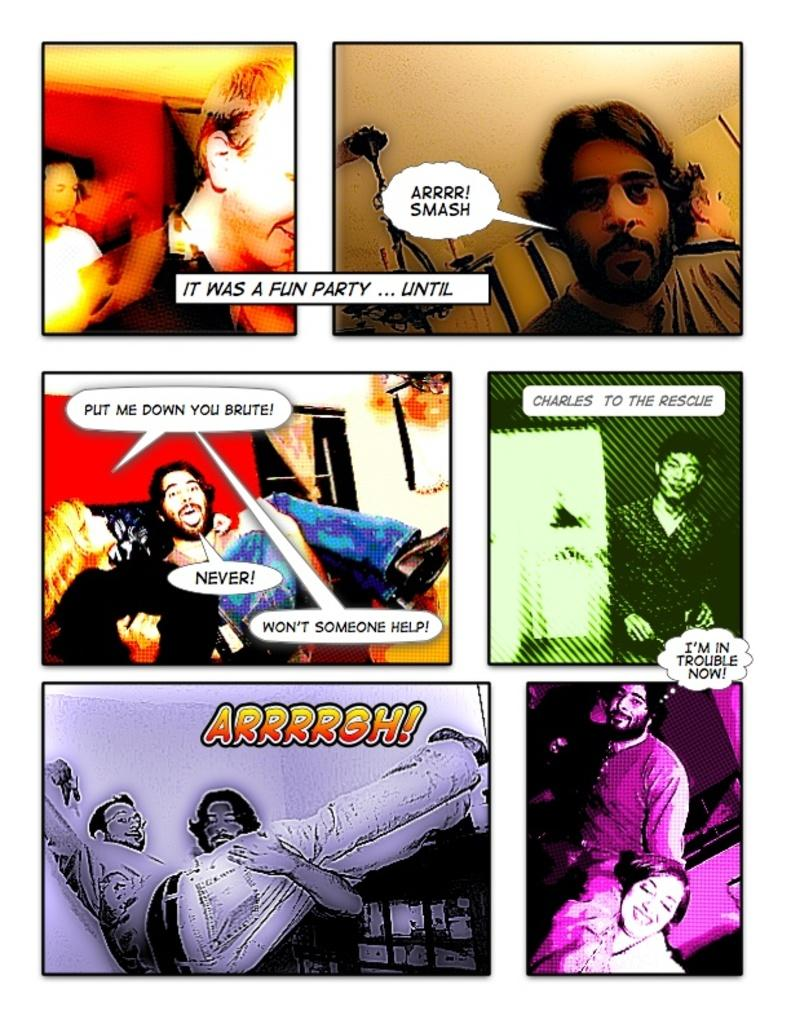What type of image is being described? The image is a collage. How many pictures are included in the collage? There are six pictures in the collage. Is there any text associated with the collage? Yes, there is text associated with the collage. How many passengers can fit in the bubble shown in the image? There is no bubble present in the image, so it is not possible to determine how many passengers could fit in it. 